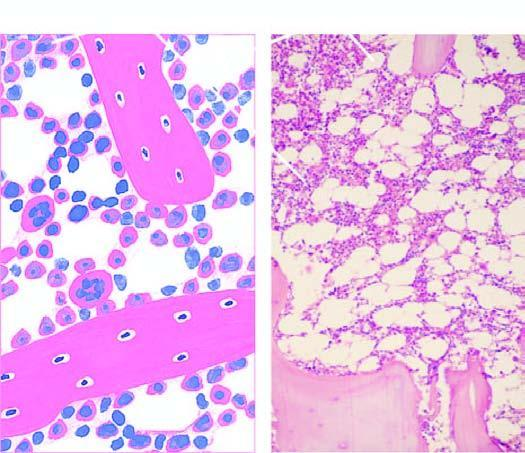what support the marrow-containing tissue?
Answer the question using a single word or phrase. Bony trabeculae 